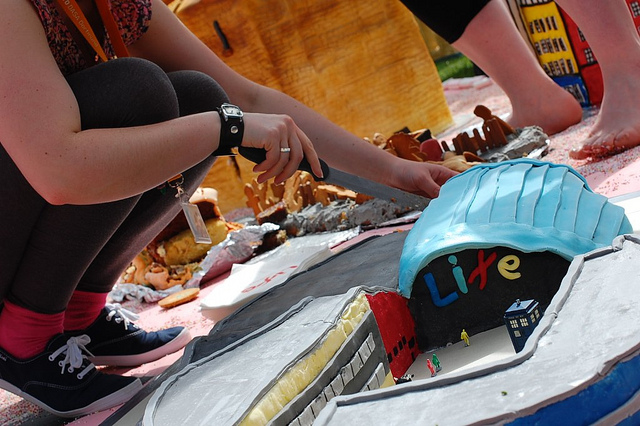Please transcribe the text information in this image. Lite 